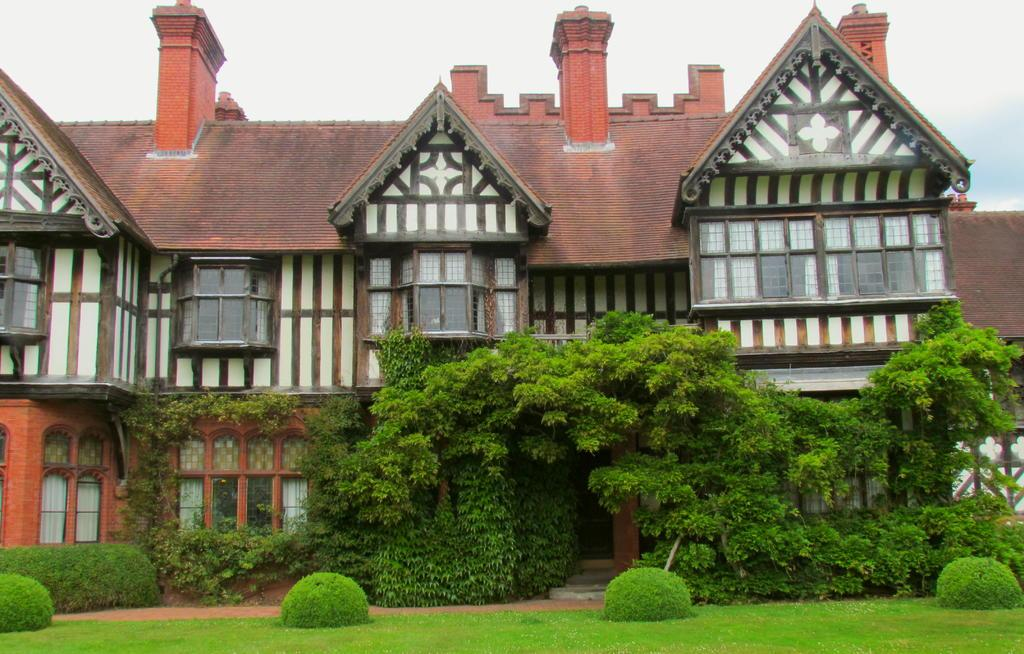What type of vegetation can be seen in the image? There are trees, plants, and grass in the image. What type of structure is present in the image? There is a building in the image. What is the color of the building? The building is brown and orange in color. What can be seen in the background of the image? The sky is visible in the background of the image. How many people are gripping the sidewalk in the image? There are no people gripping the sidewalk in the image, as there is no sidewalk present. 